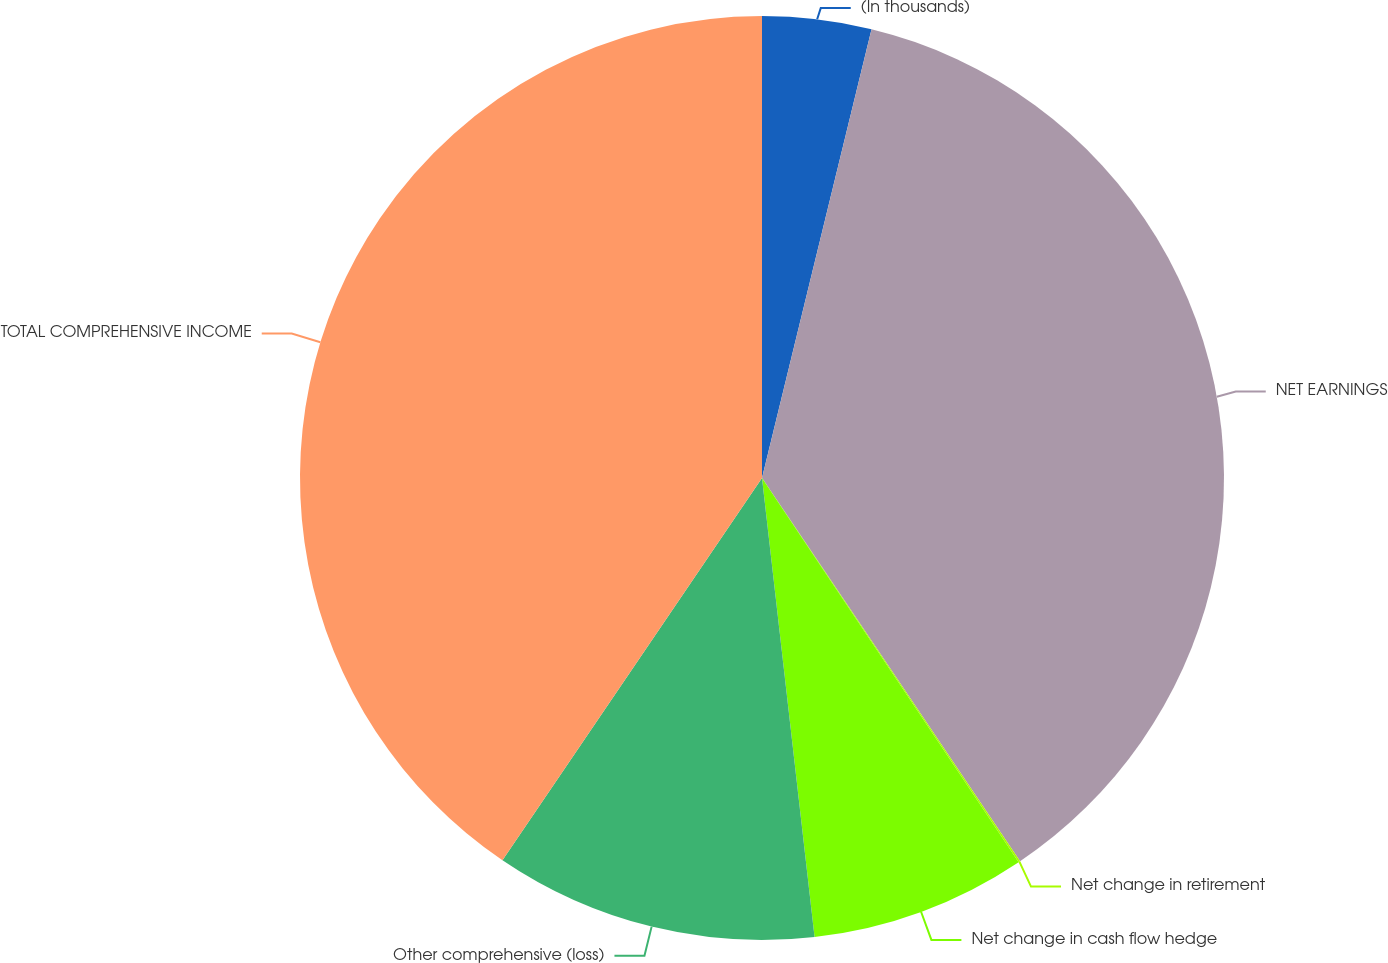Convert chart to OTSL. <chart><loc_0><loc_0><loc_500><loc_500><pie_chart><fcel>(In thousands)<fcel>NET EARNINGS<fcel>Net change in retirement<fcel>Net change in cash flow hedge<fcel>Other comprehensive (loss)<fcel>TOTAL COMPREHENSIVE INCOME<nl><fcel>3.81%<fcel>36.76%<fcel>0.06%<fcel>7.56%<fcel>11.31%<fcel>40.51%<nl></chart> 